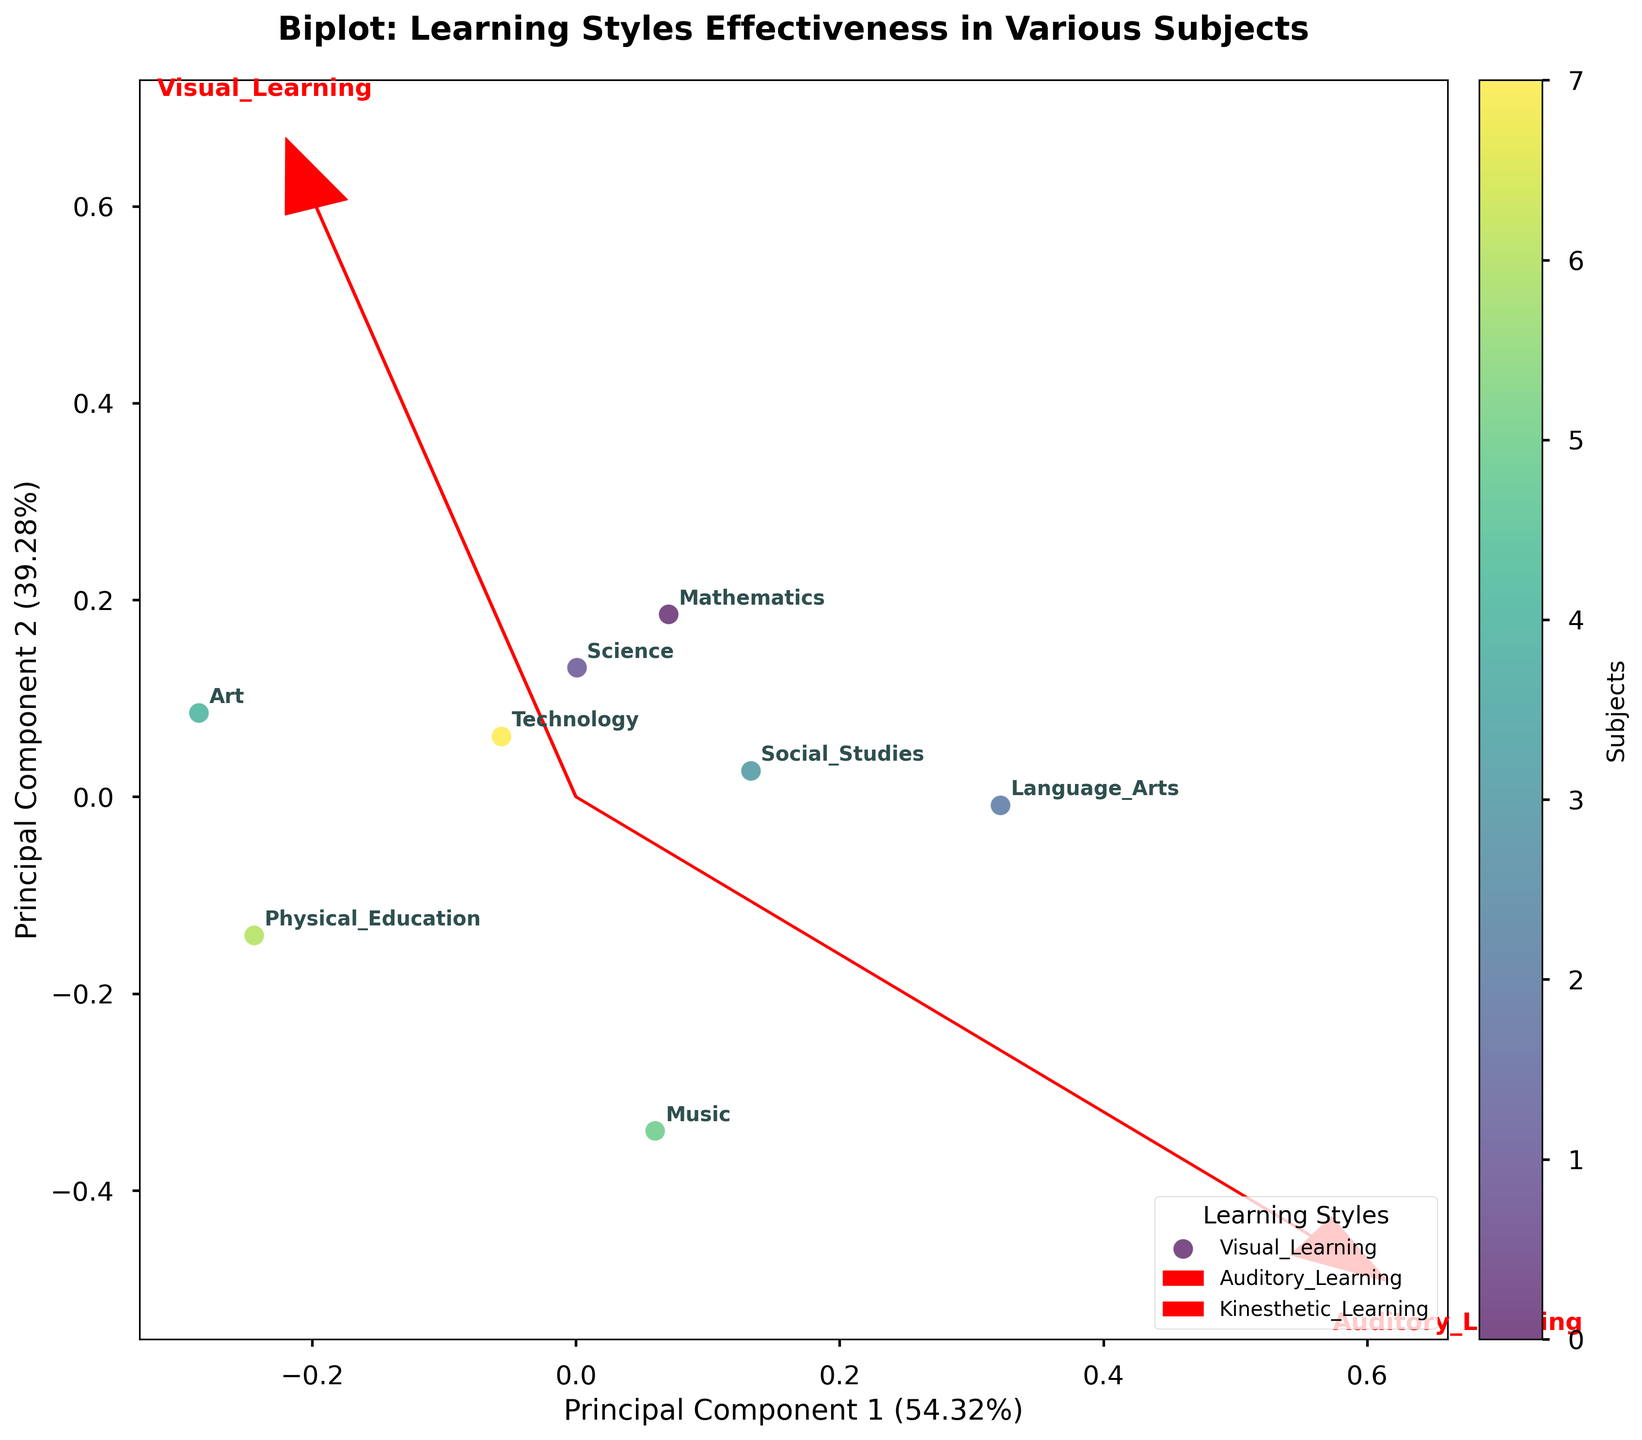What is the title of the biplot? The title of the biplot is displayed at the top in a prominent font. By reading the top center of the figure, we can identify the title.
Answer: Biplot: Learning Styles Effectiveness in Various Subjects How many subjects are displayed in the biplot? To determine the number of subjects, we count the data points annotated with subject names on the plot.
Answer: 8 Which learning style vector appears to be the longest? By observing the feature vectors drawn from the origin, the one that appears longest indicates its high influence. We visually compare the lengths of "Visual Learning," "Auditory Learning," "Kinesthetic Learning," and "Reading/Writing Learning."
Answer: Visual Learning Which subject is most influenced by the 'Reading/Writing Learning' style? To determine this, look for the subject data point closest to the direction of the 'Reading/Writing Learning' vector.
Answer: Mathematics Are 'Science' and 'Technology' closer to each other or further apart in the biplot? By examining the positions of the data points labeled 'Science' and 'Technology,' we check their proximity within the biplot.
Answer: Closer Which learning style affects 'Art' the least, based on the plot? Locate the 'Art' data point and then find the vector that has the least projection (shortest perpendicular distance) onto this data point.
Answer: Auditory Learning Considering all subjects, which learning style vectors point in a similar direction? To identify this, we examine the directions of all feature vectors and find those that are angled similarly relative to the origin.
Answer: Kinesthetic Learning and Visual Learning Between 'Mathematics' and 'Music', which one appears to be more influenced by 'Auditory Learning'? By comparing the projections of 'Mathematics' and 'Music' onto the 'Auditory Learning' vector, we identify which subject is closer.
Answer: Music Which subject is positioned closest to the origin of the biplot? We locate the origin (0, 0) and identify the data point that lies nearest to it.
Answer: Social Studies What percentage of the variance is explained by the first principal component? This information is labeled on the x-axis of the biplot, indicating the variance explained by the Principal Component 1.
Answer: 44% 